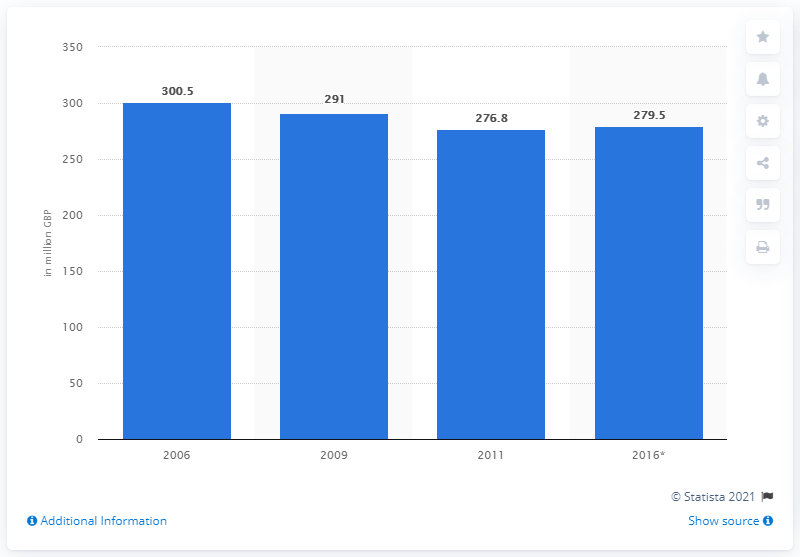Give some essential details in this illustration. According to estimates, the cost of food waste in quick service restaurants in 2016 was approximately 279.5 million dollars. In 2011, the total cost of food waste in quick service restaurants was $279.5 million. 